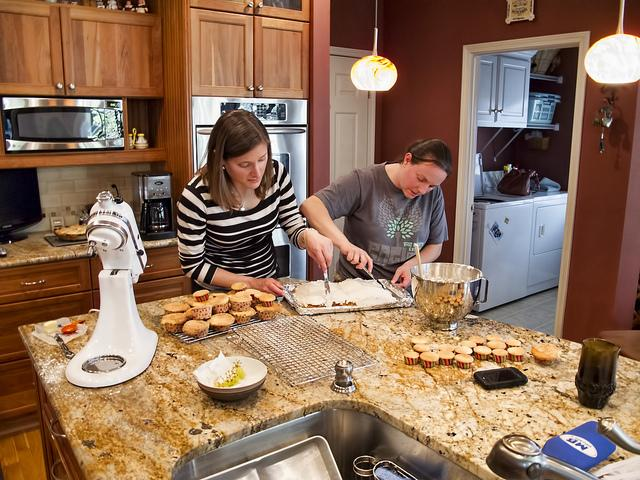What have these ladies been doing? baking 